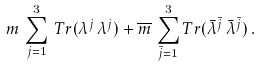<formula> <loc_0><loc_0><loc_500><loc_500>m \, \sum _ { j = 1 } ^ { 3 } \, T r ( \lambda ^ { j } \, \lambda ^ { j } ) + \overline { m } \, \sum _ { \bar { j } = 1 } ^ { 3 } T r ( \bar { \lambda } ^ { \bar { j } } \, \bar { \lambda } ^ { \bar { j } } ) \, .</formula> 